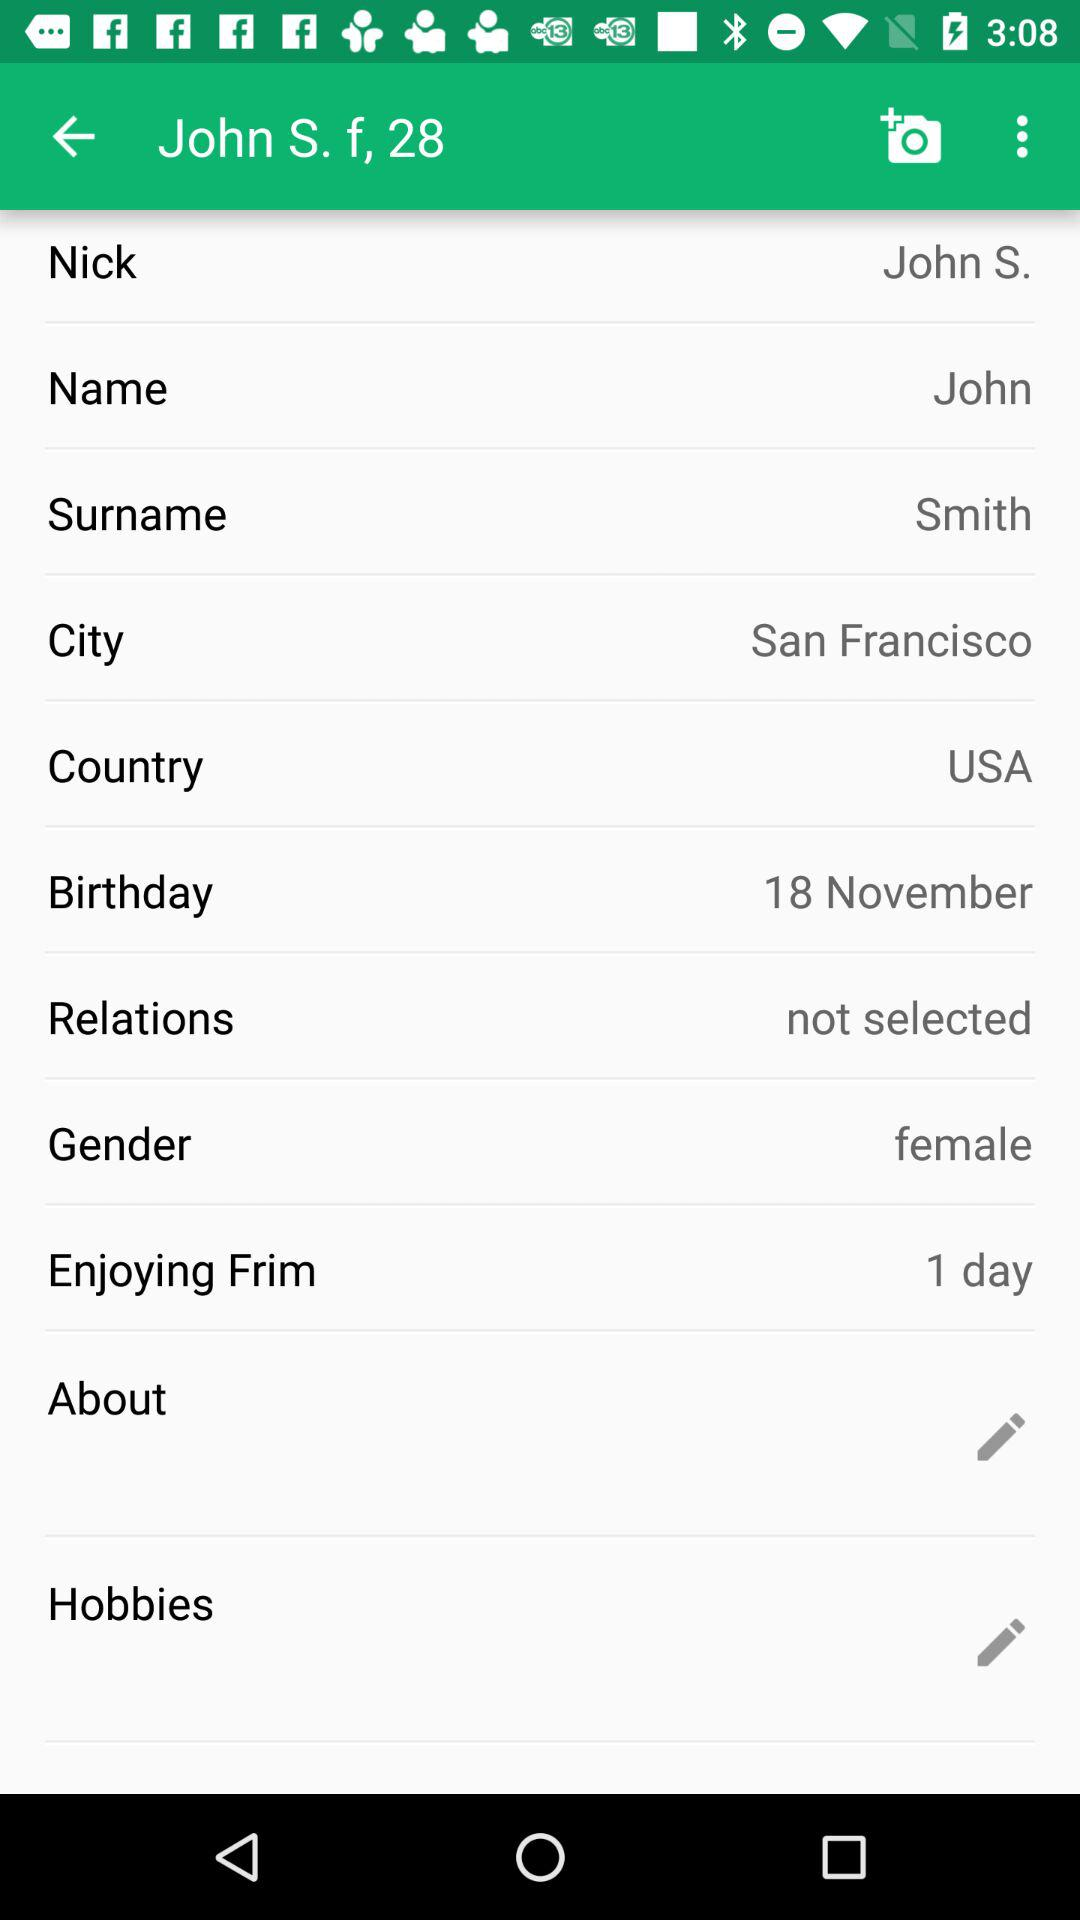What is the given name? The given name is John S. 